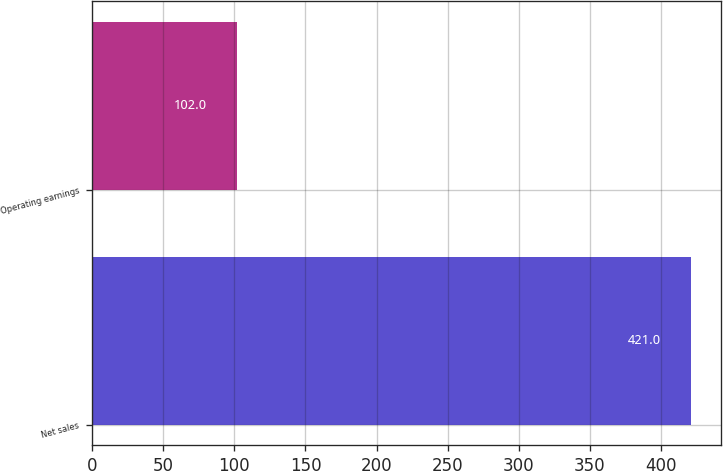Convert chart to OTSL. <chart><loc_0><loc_0><loc_500><loc_500><bar_chart><fcel>Net sales<fcel>Operating earnings<nl><fcel>421<fcel>102<nl></chart> 